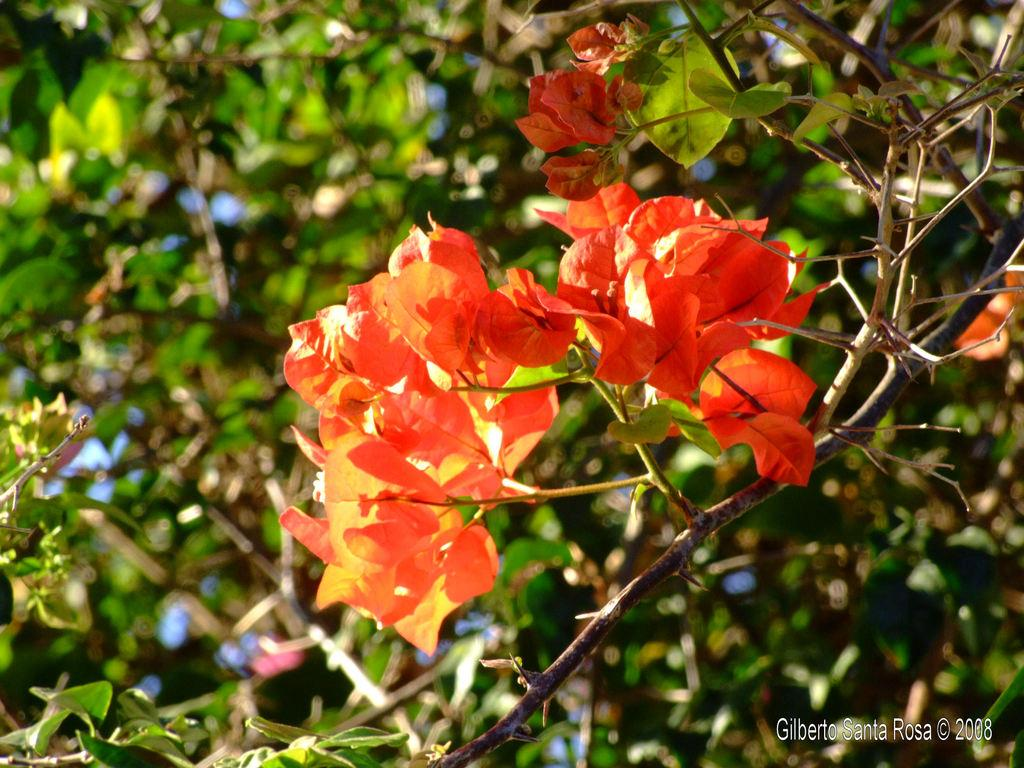What type of plant is visible in the image? There are flowers on a plant in the image. Can you describe the background of the image? The background of the image is blurry. What type of stew is being prepared in the image? There is no stew present in the image; it features a plant with flowers and a blurry background. Can you tell me how many spiders are crawling on the flowers in the image? There are no spiders present in the image; it features a plant with flowers and a blurry background. 